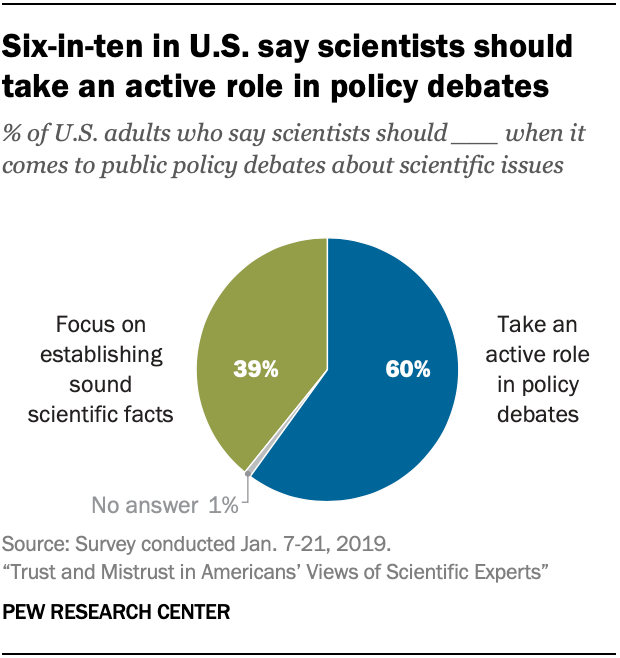Highlight a few significant elements in this photo. According to a recent survey, only 0.6% of Americans believe that scientists should not take an active role in policy debates. In a survey conducted in the United States, only 0.21% of people believed that scientists should take an active role in policy debates, while the majority, 99.79%, believed that scientists should focus on establishing sound scientific facts. 